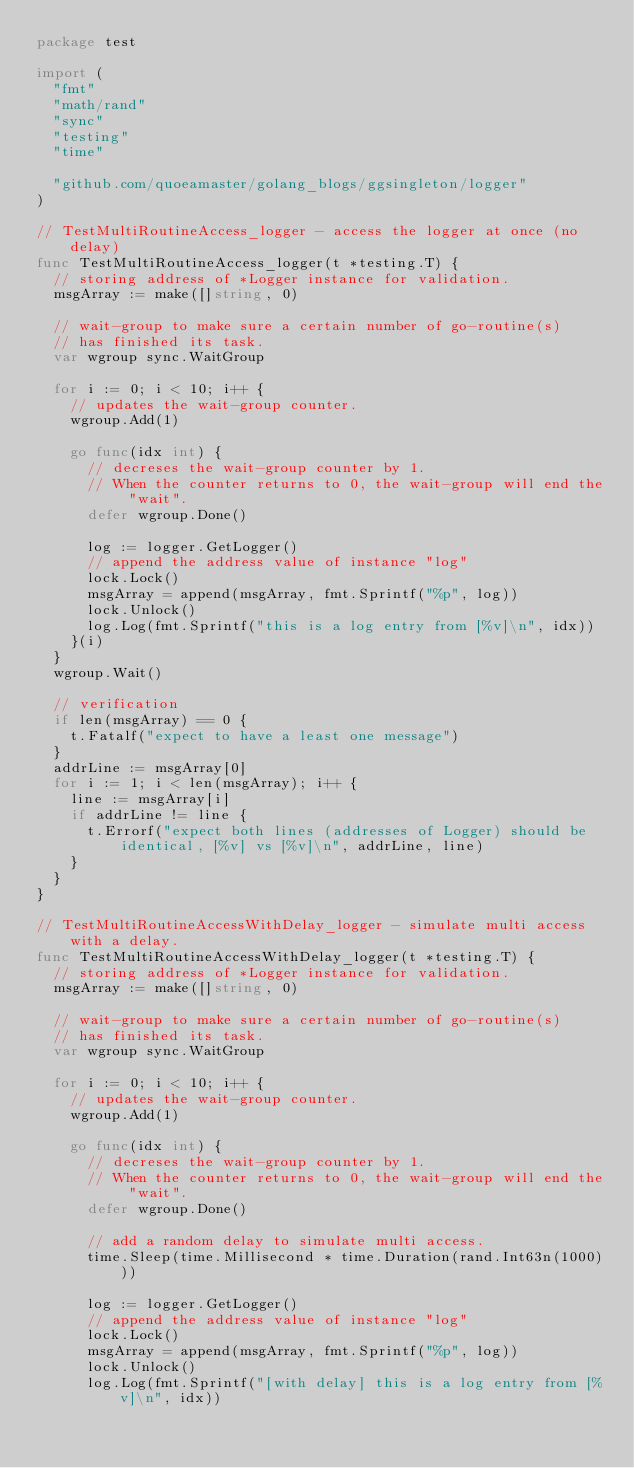Convert code to text. <code><loc_0><loc_0><loc_500><loc_500><_Go_>package test

import (
	"fmt"
	"math/rand"
	"sync"
	"testing"
	"time"

	"github.com/quoeamaster/golang_blogs/ggsingleton/logger"
)

// TestMultiRoutineAccess_logger - access the logger at once (no delay)
func TestMultiRoutineAccess_logger(t *testing.T) {
	// storing address of *Logger instance for validation.
	msgArray := make([]string, 0)

	// wait-group to make sure a certain number of go-routine(s)
	// has finished its task.
	var wgroup sync.WaitGroup

	for i := 0; i < 10; i++ {
		// updates the wait-group counter.
		wgroup.Add(1)

		go func(idx int) {
			// decreses the wait-group counter by 1.
			// When the counter returns to 0, the wait-group will end the "wait".
			defer wgroup.Done()

			log := logger.GetLogger()
			// append the address value of instance "log"
			lock.Lock()
			msgArray = append(msgArray, fmt.Sprintf("%p", log))
			lock.Unlock()
			log.Log(fmt.Sprintf("this is a log entry from [%v]\n", idx))
		}(i)
	}
	wgroup.Wait()

	// verification
	if len(msgArray) == 0 {
		t.Fatalf("expect to have a least one message")
	}
	addrLine := msgArray[0]
	for i := 1; i < len(msgArray); i++ {
		line := msgArray[i]
		if addrLine != line {
			t.Errorf("expect both lines (addresses of Logger) should be identical, [%v] vs [%v]\n", addrLine, line)
		}
	}
}

// TestMultiRoutineAccessWithDelay_logger - simulate multi access with a delay.
func TestMultiRoutineAccessWithDelay_logger(t *testing.T) {
	// storing address of *Logger instance for validation.
	msgArray := make([]string, 0)

	// wait-group to make sure a certain number of go-routine(s)
	// has finished its task.
	var wgroup sync.WaitGroup

	for i := 0; i < 10; i++ {
		// updates the wait-group counter.
		wgroup.Add(1)

		go func(idx int) {
			// decreses the wait-group counter by 1.
			// When the counter returns to 0, the wait-group will end the "wait".
			defer wgroup.Done()

			// add a random delay to simulate multi access.
			time.Sleep(time.Millisecond * time.Duration(rand.Int63n(1000)))

			log := logger.GetLogger()
			// append the address value of instance "log"
			lock.Lock()
			msgArray = append(msgArray, fmt.Sprintf("%p", log))
			lock.Unlock()
			log.Log(fmt.Sprintf("[with delay] this is a log entry from [%v]\n", idx))</code> 